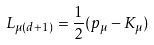<formula> <loc_0><loc_0><loc_500><loc_500>L _ { \mu ( d + 1 ) } = \frac { 1 } { 2 } ( p _ { \mu } - K _ { \mu } )</formula> 